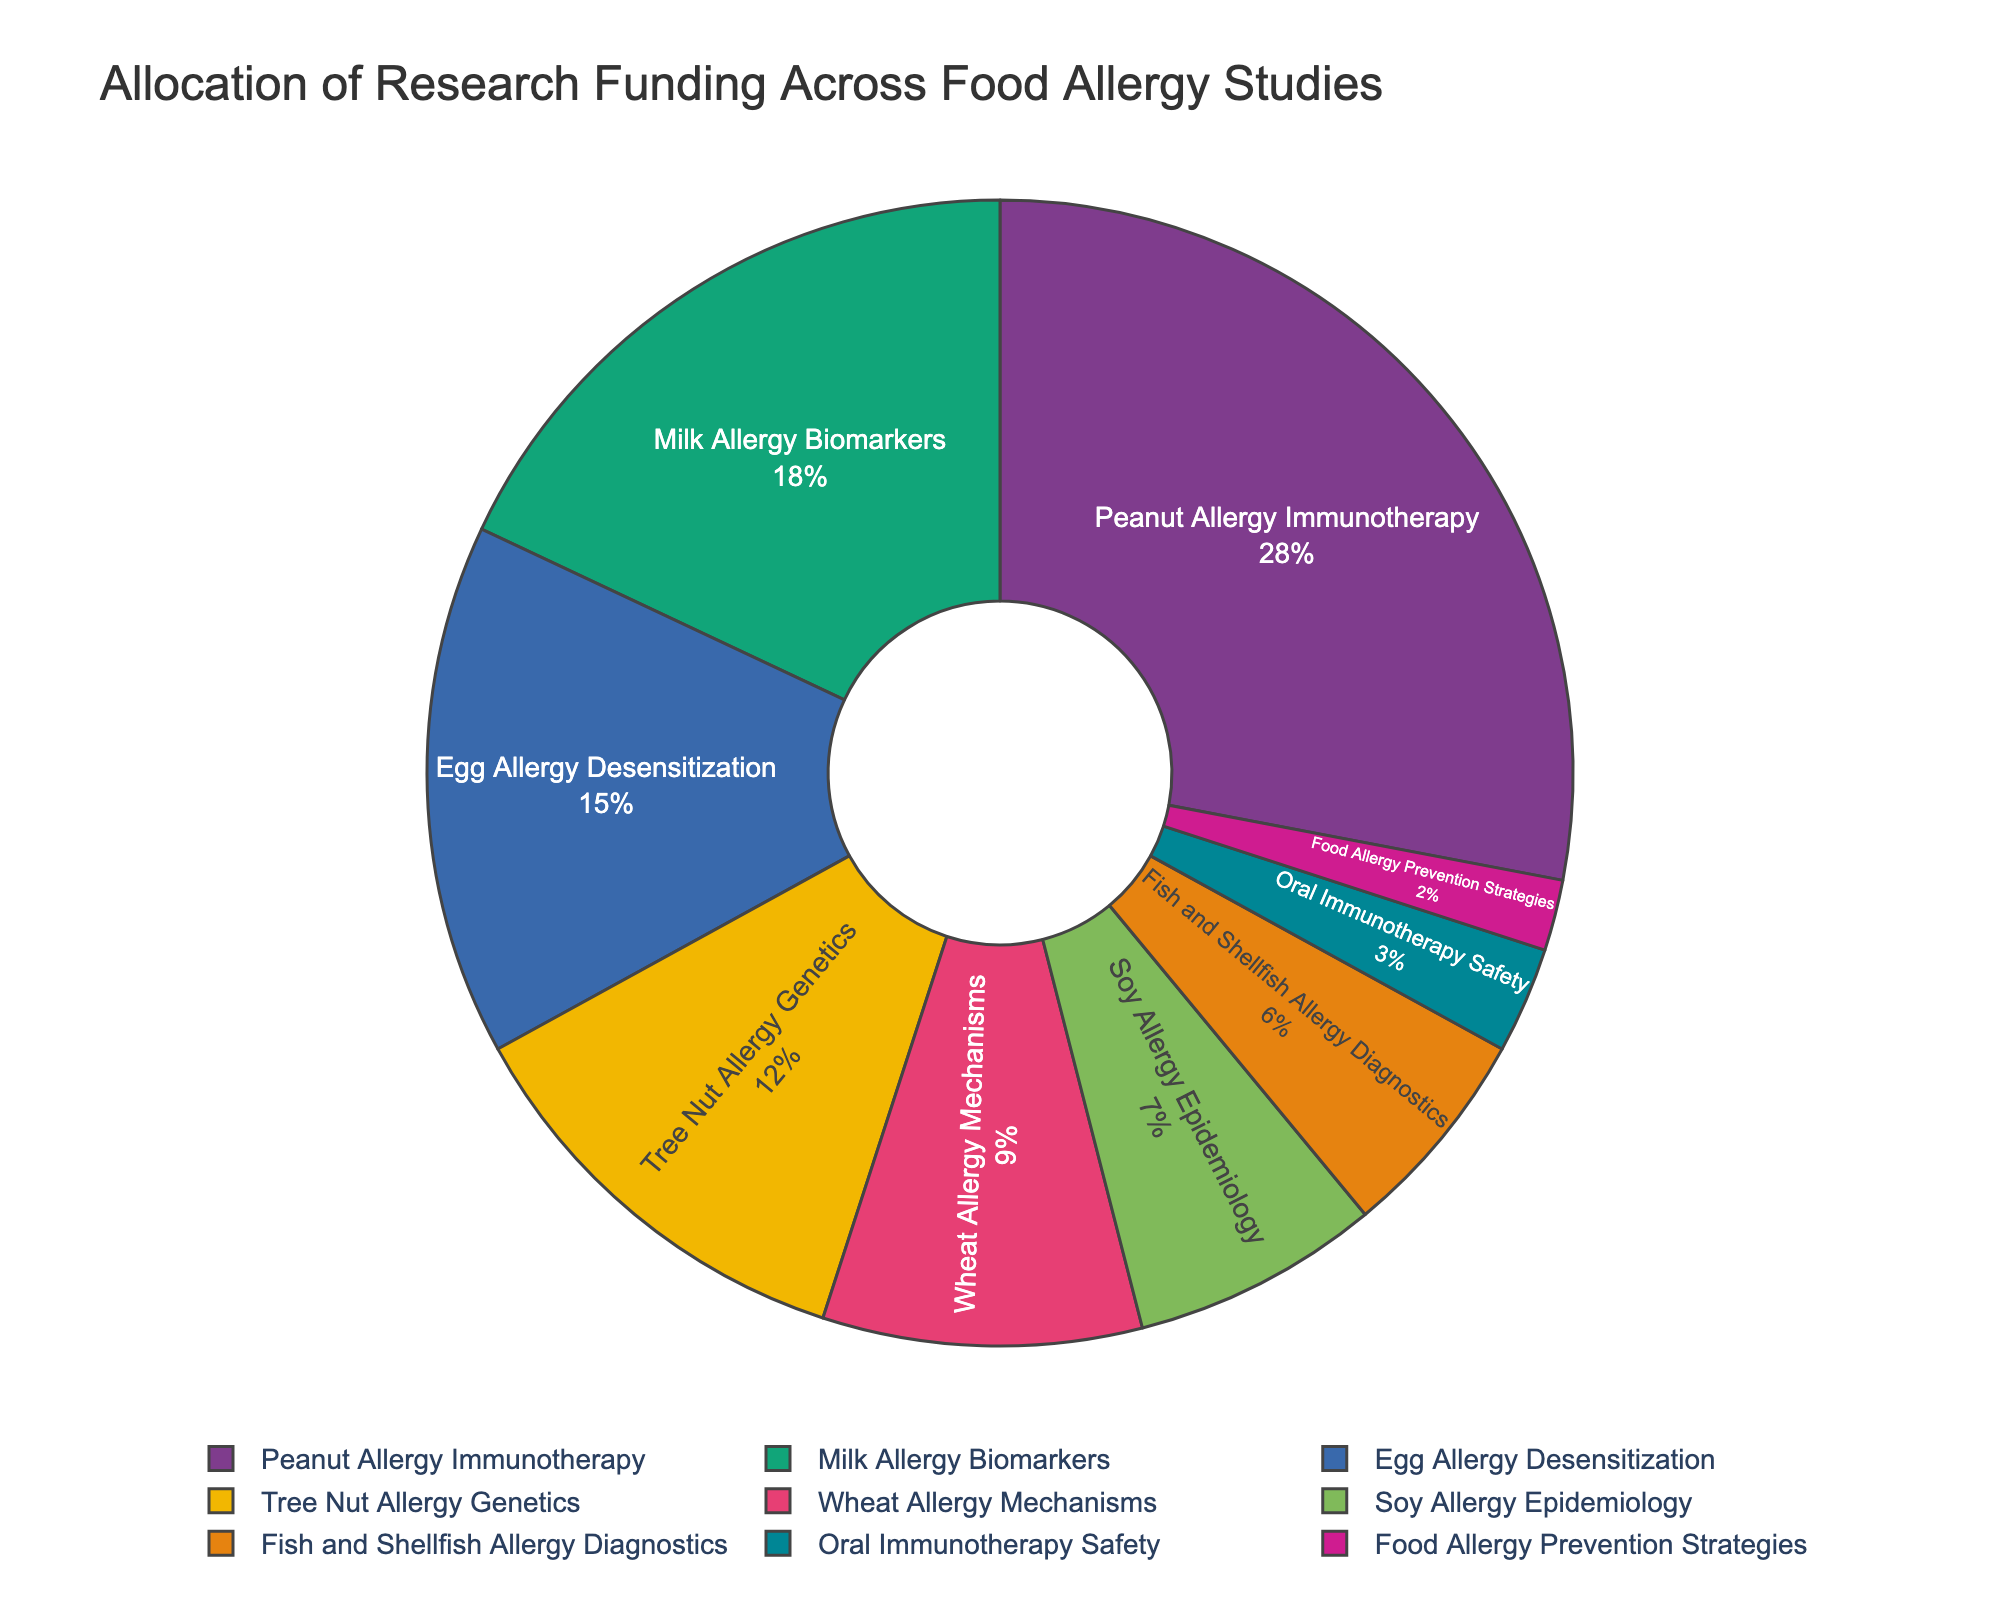Which research area received the highest funding allocation? By examining the pie chart, the slice labeled "Peanut Allergy Immunotherapy" occupies the largest proportion of the pie, indicating it received the highest funding allocation.
Answer: Peanut Allergy Immunotherapy What is the percentage difference between funding for "Peanut Allergy Immunotherapy" and "Fish and Shellfish Allergy Diagnostics"? The funding for "Peanut Allergy Immunotherapy" is 28%, and for "Fish and Shellfish Allergy Diagnostics" it is 6%. The percentage difference is calculated as 28% - 6% = 22%.
Answer: 22% Which research area received more funding, "Milk Allergy Biomarkers" or "Egg Allergy Desensitization"? By looking at the pie chart, "Milk Allergy Biomarkers" has a larger slice at 18% compared to "Egg Allergy Desensitization" which has 15%.
Answer: Milk Allergy Biomarkers What is the combined funding allocation percentage for "Tree Nut Allergy Genetics" and "Wheat Allergy Mechanisms"? The funding for "Tree Nut Allergy Genetics" is 12%, and for "Wheat Allergy Mechanisms" it is 9%. Adding these percentages gives 12% + 9% = 21%.
Answer: 21% How many research areas received funding allocations less than 10%? By examining the labels on the pie chart, the research areas with funding allocations less than 10% are "Wheat Allergy Mechanisms" (9%), "Soy Allergy Epidemiology" (7%), "Fish and Shellfish Allergy Diagnostics" (6%), "Oral Immunotherapy Safety" (3%), and "Food Allergy Prevention Strategies" (2%). There are 5 such research areas.
Answer: 5 What percentage of the total funding is allocated to "Oral Immunotherapy Safety" and "Food Allergy Prevention Strategies" combined? The funding for "Oral Immunotherapy Safety" is 3%, and for "Food Allergy Prevention Strategies" it is 2%. Adding these percentages gives 3% + 2% = 5%.
Answer: 5% Which color represents "Egg Allergy Desensitization"? By looking at the pie chart and its legend, "Egg Allergy Desensitization" is represented by a specific color, which in the selected palette is light blue.
Answer: Light blue What is the overall distribution of funding (in terms of pie slices) for studies related to allergen components like "Milk Allergy Biomarkers" and "Tree Nut Allergy Genetics"? The slices for "Milk Allergy Biomarkers" and "Tree Nut Allergy Genetics" occupy 18% and 12% of the pie respectively, thus together they cover a significant part of the chart.
Answer: Significant part Is funding for "Wheat Allergy Mechanisms" greater than half of the funding for "Milk Allergy Biomarkers"? Examining the chart, funding for "Wheat Allergy Mechanisms" is 9%, and half of the funding for "Milk Allergy Biomarkers" is 18% / 2 = 9%. Since 9% is equal to 9%, funding for "Wheat Allergy Mechanisms" is exactly half of the funding for "Milk Allergy Biomarkers".
Answer: Equal What is the least funded research area? By examining the chart, the slice labeled "Food Allergy Prevention Strategies" is the smallest, indicating it received the least funding allocation of 2%.
Answer: Food Allergy Prevention Strategies 